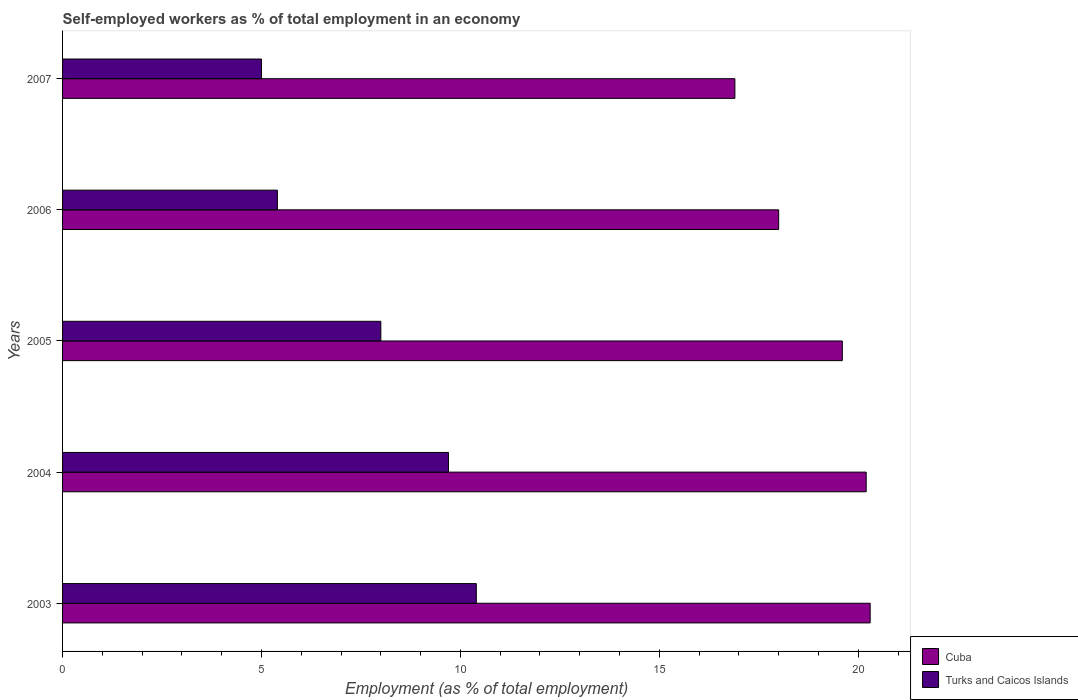How many bars are there on the 2nd tick from the top?
Offer a terse response. 2. In how many cases, is the number of bars for a given year not equal to the number of legend labels?
Offer a terse response. 0. What is the percentage of self-employed workers in Cuba in 2007?
Offer a terse response. 16.9. Across all years, what is the maximum percentage of self-employed workers in Cuba?
Offer a very short reply. 20.3. In which year was the percentage of self-employed workers in Turks and Caicos Islands minimum?
Your answer should be compact. 2007. What is the total percentage of self-employed workers in Cuba in the graph?
Give a very brief answer. 95. What is the difference between the percentage of self-employed workers in Cuba in 2004 and that in 2007?
Provide a short and direct response. 3.3. What is the difference between the percentage of self-employed workers in Turks and Caicos Islands in 2007 and the percentage of self-employed workers in Cuba in 2003?
Make the answer very short. -15.3. What is the average percentage of self-employed workers in Turks and Caicos Islands per year?
Provide a short and direct response. 7.7. In the year 2006, what is the difference between the percentage of self-employed workers in Turks and Caicos Islands and percentage of self-employed workers in Cuba?
Offer a very short reply. -12.6. In how many years, is the percentage of self-employed workers in Turks and Caicos Islands greater than 19 %?
Keep it short and to the point. 0. What is the ratio of the percentage of self-employed workers in Turks and Caicos Islands in 2004 to that in 2006?
Provide a succinct answer. 1.8. What is the difference between the highest and the second highest percentage of self-employed workers in Turks and Caicos Islands?
Your answer should be very brief. 0.7. What is the difference between the highest and the lowest percentage of self-employed workers in Turks and Caicos Islands?
Your answer should be very brief. 5.4. Is the sum of the percentage of self-employed workers in Cuba in 2004 and 2007 greater than the maximum percentage of self-employed workers in Turks and Caicos Islands across all years?
Your response must be concise. Yes. What does the 2nd bar from the top in 2004 represents?
Your answer should be very brief. Cuba. What does the 2nd bar from the bottom in 2007 represents?
Your answer should be very brief. Turks and Caicos Islands. How many bars are there?
Make the answer very short. 10. Are all the bars in the graph horizontal?
Your answer should be very brief. Yes. Does the graph contain any zero values?
Provide a short and direct response. No. Does the graph contain grids?
Your answer should be very brief. No. How many legend labels are there?
Provide a succinct answer. 2. How are the legend labels stacked?
Keep it short and to the point. Vertical. What is the title of the graph?
Ensure brevity in your answer.  Self-employed workers as % of total employment in an economy. What is the label or title of the X-axis?
Ensure brevity in your answer.  Employment (as % of total employment). What is the Employment (as % of total employment) in Cuba in 2003?
Provide a succinct answer. 20.3. What is the Employment (as % of total employment) in Turks and Caicos Islands in 2003?
Keep it short and to the point. 10.4. What is the Employment (as % of total employment) in Cuba in 2004?
Give a very brief answer. 20.2. What is the Employment (as % of total employment) in Turks and Caicos Islands in 2004?
Ensure brevity in your answer.  9.7. What is the Employment (as % of total employment) in Cuba in 2005?
Offer a terse response. 19.6. What is the Employment (as % of total employment) of Turks and Caicos Islands in 2005?
Your answer should be compact. 8. What is the Employment (as % of total employment) of Turks and Caicos Islands in 2006?
Your answer should be compact. 5.4. What is the Employment (as % of total employment) of Cuba in 2007?
Provide a short and direct response. 16.9. Across all years, what is the maximum Employment (as % of total employment) in Cuba?
Keep it short and to the point. 20.3. Across all years, what is the maximum Employment (as % of total employment) of Turks and Caicos Islands?
Your answer should be very brief. 10.4. Across all years, what is the minimum Employment (as % of total employment) of Cuba?
Provide a succinct answer. 16.9. What is the total Employment (as % of total employment) in Turks and Caicos Islands in the graph?
Make the answer very short. 38.5. What is the difference between the Employment (as % of total employment) in Cuba in 2003 and that in 2004?
Offer a very short reply. 0.1. What is the difference between the Employment (as % of total employment) in Cuba in 2003 and that in 2005?
Your response must be concise. 0.7. What is the difference between the Employment (as % of total employment) of Turks and Caicos Islands in 2003 and that in 2005?
Make the answer very short. 2.4. What is the difference between the Employment (as % of total employment) in Turks and Caicos Islands in 2004 and that in 2005?
Offer a very short reply. 1.7. What is the difference between the Employment (as % of total employment) in Turks and Caicos Islands in 2004 and that in 2006?
Offer a very short reply. 4.3. What is the difference between the Employment (as % of total employment) in Cuba in 2004 and that in 2007?
Your answer should be compact. 3.3. What is the difference between the Employment (as % of total employment) in Turks and Caicos Islands in 2004 and that in 2007?
Your answer should be very brief. 4.7. What is the difference between the Employment (as % of total employment) of Turks and Caicos Islands in 2005 and that in 2006?
Give a very brief answer. 2.6. What is the difference between the Employment (as % of total employment) in Turks and Caicos Islands in 2005 and that in 2007?
Keep it short and to the point. 3. What is the difference between the Employment (as % of total employment) of Cuba in 2003 and the Employment (as % of total employment) of Turks and Caicos Islands in 2006?
Your answer should be very brief. 14.9. What is the difference between the Employment (as % of total employment) of Cuba in 2003 and the Employment (as % of total employment) of Turks and Caicos Islands in 2007?
Make the answer very short. 15.3. What is the difference between the Employment (as % of total employment) in Cuba in 2004 and the Employment (as % of total employment) in Turks and Caicos Islands in 2005?
Provide a short and direct response. 12.2. What is the difference between the Employment (as % of total employment) in Cuba in 2004 and the Employment (as % of total employment) in Turks and Caicos Islands in 2006?
Your response must be concise. 14.8. What is the difference between the Employment (as % of total employment) of Cuba in 2004 and the Employment (as % of total employment) of Turks and Caicos Islands in 2007?
Your answer should be very brief. 15.2. What is the difference between the Employment (as % of total employment) of Cuba in 2005 and the Employment (as % of total employment) of Turks and Caicos Islands in 2007?
Provide a succinct answer. 14.6. What is the average Employment (as % of total employment) of Cuba per year?
Offer a terse response. 19. In the year 2005, what is the difference between the Employment (as % of total employment) in Cuba and Employment (as % of total employment) in Turks and Caicos Islands?
Ensure brevity in your answer.  11.6. What is the ratio of the Employment (as % of total employment) in Turks and Caicos Islands in 2003 to that in 2004?
Your answer should be very brief. 1.07. What is the ratio of the Employment (as % of total employment) of Cuba in 2003 to that in 2005?
Your response must be concise. 1.04. What is the ratio of the Employment (as % of total employment) in Turks and Caicos Islands in 2003 to that in 2005?
Keep it short and to the point. 1.3. What is the ratio of the Employment (as % of total employment) of Cuba in 2003 to that in 2006?
Provide a short and direct response. 1.13. What is the ratio of the Employment (as % of total employment) of Turks and Caicos Islands in 2003 to that in 2006?
Your answer should be compact. 1.93. What is the ratio of the Employment (as % of total employment) of Cuba in 2003 to that in 2007?
Make the answer very short. 1.2. What is the ratio of the Employment (as % of total employment) in Turks and Caicos Islands in 2003 to that in 2007?
Provide a short and direct response. 2.08. What is the ratio of the Employment (as % of total employment) in Cuba in 2004 to that in 2005?
Your response must be concise. 1.03. What is the ratio of the Employment (as % of total employment) of Turks and Caicos Islands in 2004 to that in 2005?
Your answer should be very brief. 1.21. What is the ratio of the Employment (as % of total employment) of Cuba in 2004 to that in 2006?
Provide a short and direct response. 1.12. What is the ratio of the Employment (as % of total employment) of Turks and Caicos Islands in 2004 to that in 2006?
Provide a short and direct response. 1.8. What is the ratio of the Employment (as % of total employment) of Cuba in 2004 to that in 2007?
Offer a terse response. 1.2. What is the ratio of the Employment (as % of total employment) in Turks and Caicos Islands in 2004 to that in 2007?
Your response must be concise. 1.94. What is the ratio of the Employment (as % of total employment) in Cuba in 2005 to that in 2006?
Your answer should be very brief. 1.09. What is the ratio of the Employment (as % of total employment) of Turks and Caicos Islands in 2005 to that in 2006?
Give a very brief answer. 1.48. What is the ratio of the Employment (as % of total employment) of Cuba in 2005 to that in 2007?
Provide a succinct answer. 1.16. What is the ratio of the Employment (as % of total employment) in Turks and Caicos Islands in 2005 to that in 2007?
Offer a very short reply. 1.6. What is the ratio of the Employment (as % of total employment) of Cuba in 2006 to that in 2007?
Provide a short and direct response. 1.07. What is the difference between the highest and the second highest Employment (as % of total employment) of Turks and Caicos Islands?
Keep it short and to the point. 0.7. 